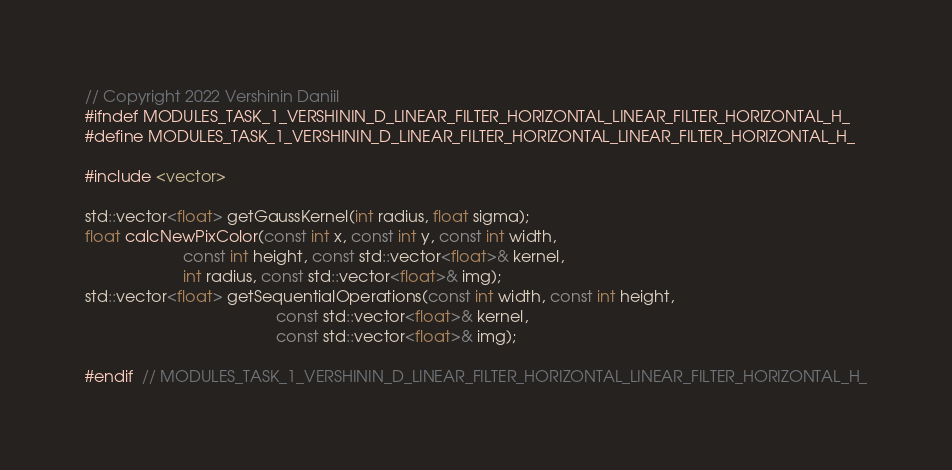<code> <loc_0><loc_0><loc_500><loc_500><_C_>// Copyright 2022 Vershinin Daniil
#ifndef MODULES_TASK_1_VERSHININ_D_LINEAR_FILTER_HORIZONTAL_LINEAR_FILTER_HORIZONTAL_H_
#define MODULES_TASK_1_VERSHININ_D_LINEAR_FILTER_HORIZONTAL_LINEAR_FILTER_HORIZONTAL_H_

#include <vector>

std::vector<float> getGaussKernel(int radius, float sigma);
float calcNewPixColor(const int x, const int y, const int width,
                      const int height, const std::vector<float>& kernel,
                      int radius, const std::vector<float>& img);
std::vector<float> getSequentialOperations(const int width, const int height,
                                           const std::vector<float>& kernel,
                                           const std::vector<float>& img);

#endif  // MODULES_TASK_1_VERSHININ_D_LINEAR_FILTER_HORIZONTAL_LINEAR_FILTER_HORIZONTAL_H_
</code> 